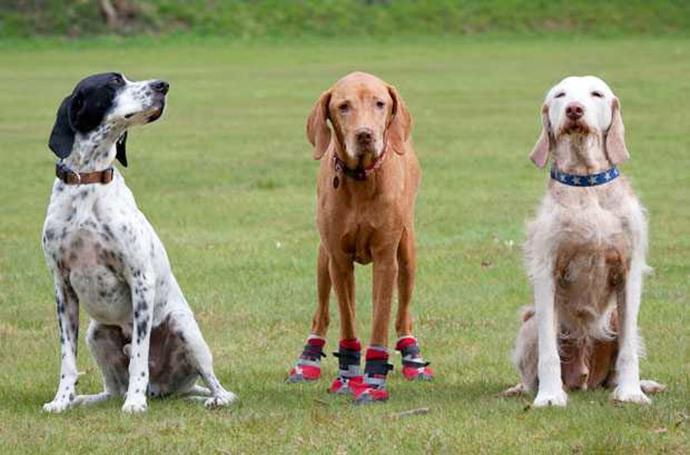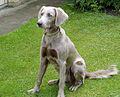The first image is the image on the left, the second image is the image on the right. Considering the images on both sides, is "The left image shows a row of three dogs with upright heads, and the right image shows one upright dog wearing a collar." valid? Answer yes or no. Yes. The first image is the image on the left, the second image is the image on the right. Given the left and right images, does the statement "In the image on the left there are 3 dogs." hold true? Answer yes or no. Yes. 